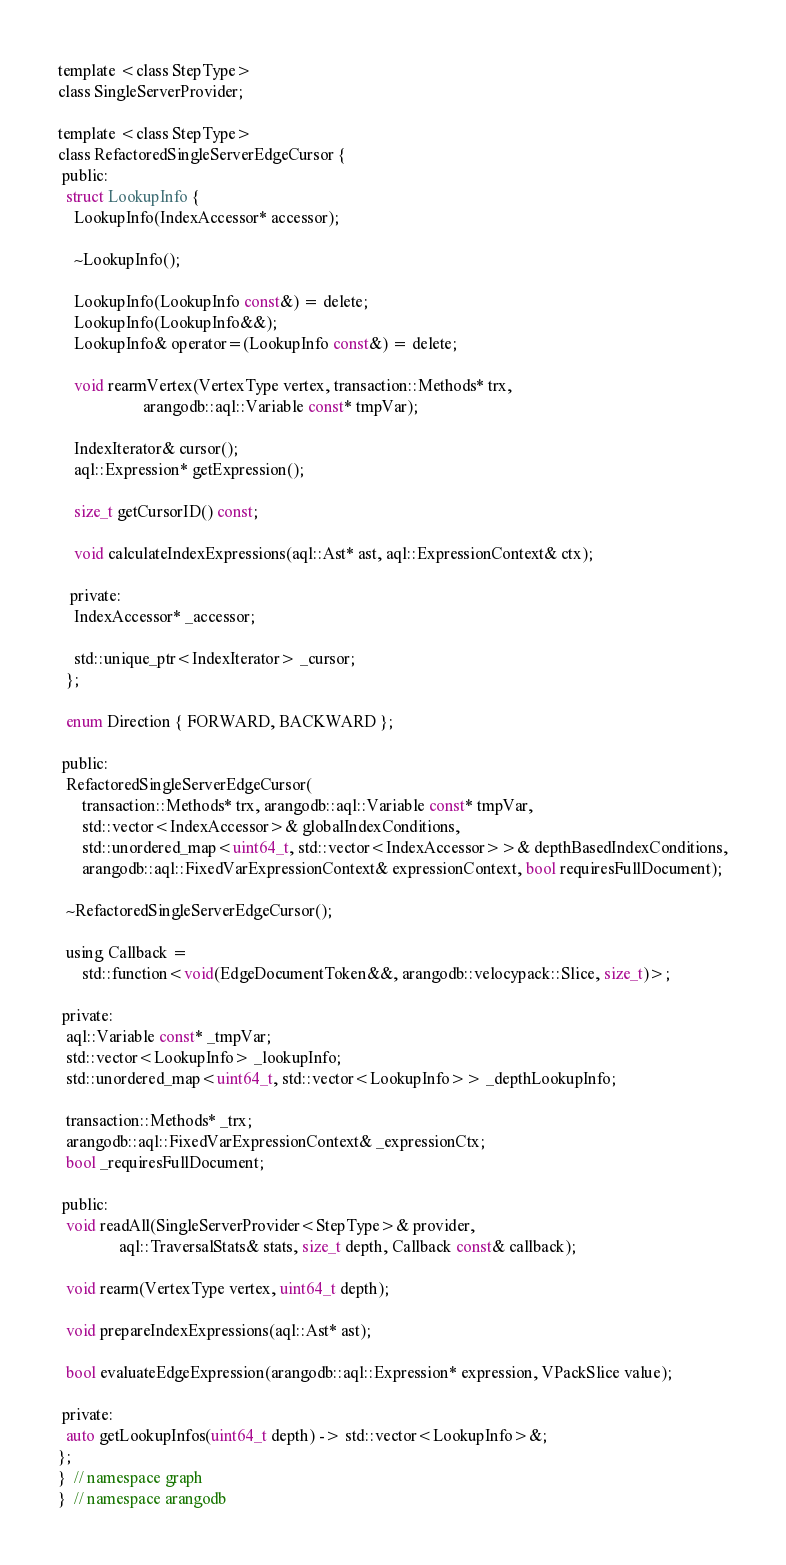<code> <loc_0><loc_0><loc_500><loc_500><_C_>
template <class StepType>
class SingleServerProvider;

template <class StepType>
class RefactoredSingleServerEdgeCursor {
 public:
  struct LookupInfo {
    LookupInfo(IndexAccessor* accessor);

    ~LookupInfo();

    LookupInfo(LookupInfo const&) = delete;
    LookupInfo(LookupInfo&&);
    LookupInfo& operator=(LookupInfo const&) = delete;

    void rearmVertex(VertexType vertex, transaction::Methods* trx,
                     arangodb::aql::Variable const* tmpVar);

    IndexIterator& cursor();
    aql::Expression* getExpression();

    size_t getCursorID() const;

    void calculateIndexExpressions(aql::Ast* ast, aql::ExpressionContext& ctx);

   private:
    IndexAccessor* _accessor;

    std::unique_ptr<IndexIterator> _cursor;
  };

  enum Direction { FORWARD, BACKWARD };

 public:
  RefactoredSingleServerEdgeCursor(
      transaction::Methods* trx, arangodb::aql::Variable const* tmpVar,
      std::vector<IndexAccessor>& globalIndexConditions,
      std::unordered_map<uint64_t, std::vector<IndexAccessor>>& depthBasedIndexConditions,
      arangodb::aql::FixedVarExpressionContext& expressionContext, bool requiresFullDocument);

  ~RefactoredSingleServerEdgeCursor();

  using Callback =
      std::function<void(EdgeDocumentToken&&, arangodb::velocypack::Slice, size_t)>;

 private:
  aql::Variable const* _tmpVar;
  std::vector<LookupInfo> _lookupInfo;
  std::unordered_map<uint64_t, std::vector<LookupInfo>> _depthLookupInfo;

  transaction::Methods* _trx;
  arangodb::aql::FixedVarExpressionContext& _expressionCtx;
  bool _requiresFullDocument;

 public:
  void readAll(SingleServerProvider<StepType>& provider,
               aql::TraversalStats& stats, size_t depth, Callback const& callback);

  void rearm(VertexType vertex, uint64_t depth);

  void prepareIndexExpressions(aql::Ast* ast);

  bool evaluateEdgeExpression(arangodb::aql::Expression* expression, VPackSlice value);

 private:
  auto getLookupInfos(uint64_t depth) -> std::vector<LookupInfo>&;
};
}  // namespace graph
}  // namespace arangodb
</code> 